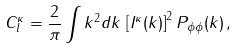Convert formula to latex. <formula><loc_0><loc_0><loc_500><loc_500>C _ { l } ^ { \kappa } = \frac { 2 } { \pi } \int k ^ { 2 } d k \, \left [ I ^ { \kappa } ( k ) \right ] ^ { 2 } P _ { \phi \phi } ( k ) \, ,</formula> 